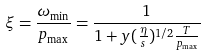<formula> <loc_0><loc_0><loc_500><loc_500>\xi = \frac { \omega _ { \min } } { p _ { \max } } = \frac { 1 } { 1 + y ( \frac { \eta } { s } ) ^ { 1 / 2 } \frac { T } { p _ { \max } } }</formula> 